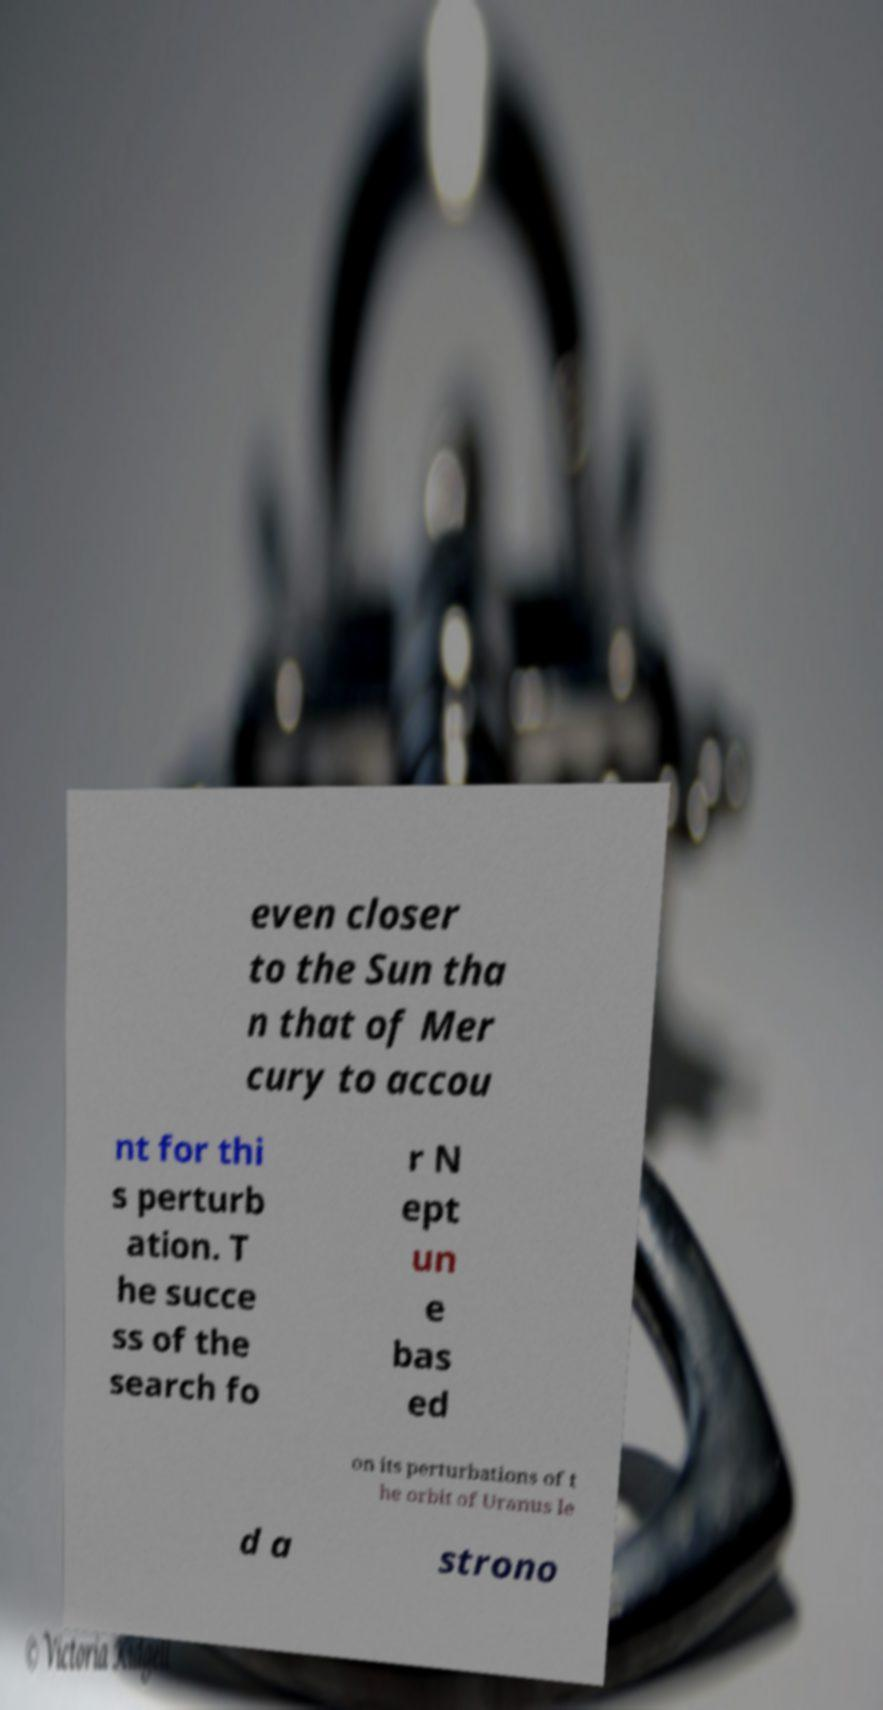Could you assist in decoding the text presented in this image and type it out clearly? even closer to the Sun tha n that of Mer cury to accou nt for thi s perturb ation. T he succe ss of the search fo r N ept un e bas ed on its perturbations of t he orbit of Uranus le d a strono 